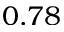<formula> <loc_0><loc_0><loc_500><loc_500>0 . 7 8</formula> 